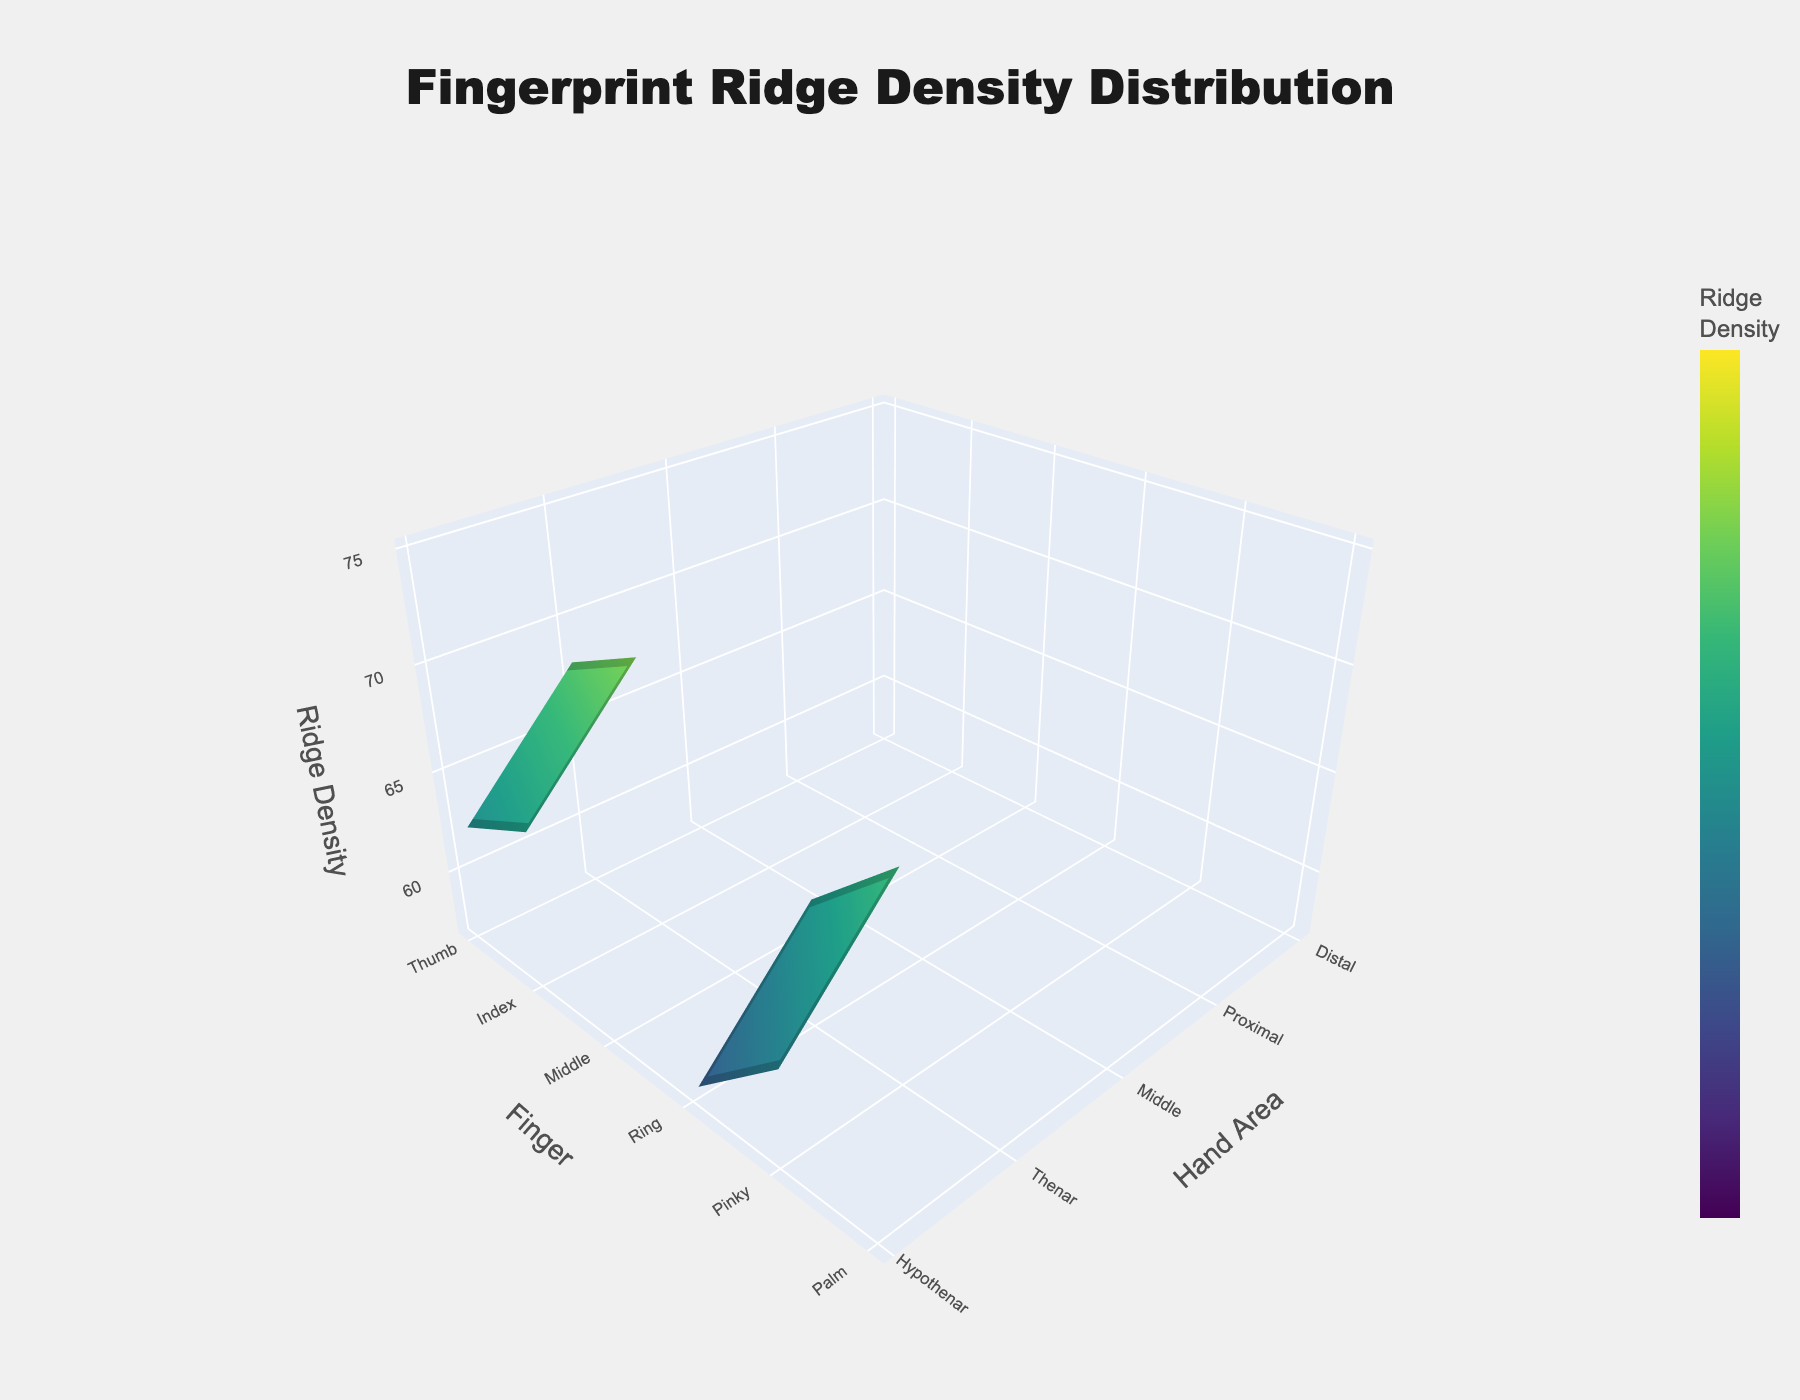What is the title of the plot? The title is clearly displayed at the top of the plot and reads "Fingerprint Ridge Density Distribution".
Answer: Fingerprint Ridge Density Distribution Which hand area has the lowest ridge density? Looking at the lowest point on the Z-axis, we correlate it to the X-axis indicating the hand area. The lowest ridge density value is 50, corresponding to the Hypothenar area of the Palm.
Answer: Hypothenar What is the ridge density at the distal area of the middle finger? Locate the intersection of the Middle finger along the Y-axis and the Distal area along the X-axis. The corresponding Z-value for this point is 75.
Answer: 75 Which finger has the highest ridge density overall? Compare the ridge density values for each finger at all given areas. The middle finger at the distal area has the highest ridge density of 75, which is the maximum value in the graph, indicating it has the highest overall.
Answer: Middle Which area has higher ridge density: Index Middle or Ring Proximal? Compare the Z-values at the intersection of Index Middle (68) and Ring Proximal (61) on the surface plot. 68 is greater than 61.
Answer: Index Middle What is the difference in ridge density between the thumb proximal and pinky middle regions? Locate the ridge density values for Thumb Proximal (58) and Pinky Middle (63). Subtract the values: 63 - 58 = 5.
Answer: 5 What is the average ridge density for the entire Palm area? Calculate the average by summing the ridge densities for Thenar (52), Hypothenar (50), and Interdigital (55), then dividing by 3. The sum is 52 + 50 + 55 = 157. The average is 157 / 3 = 52.33.
Answer: 52.33 How does the ridge density change from the proximal to distal areas on the index finger? Look at the ridge densities on the Index finger for proximal (62), middle (68), and distal (72) areas. The ridge density increases from proximal to distal: 62 → 68 → 72.
Answer: Increases 